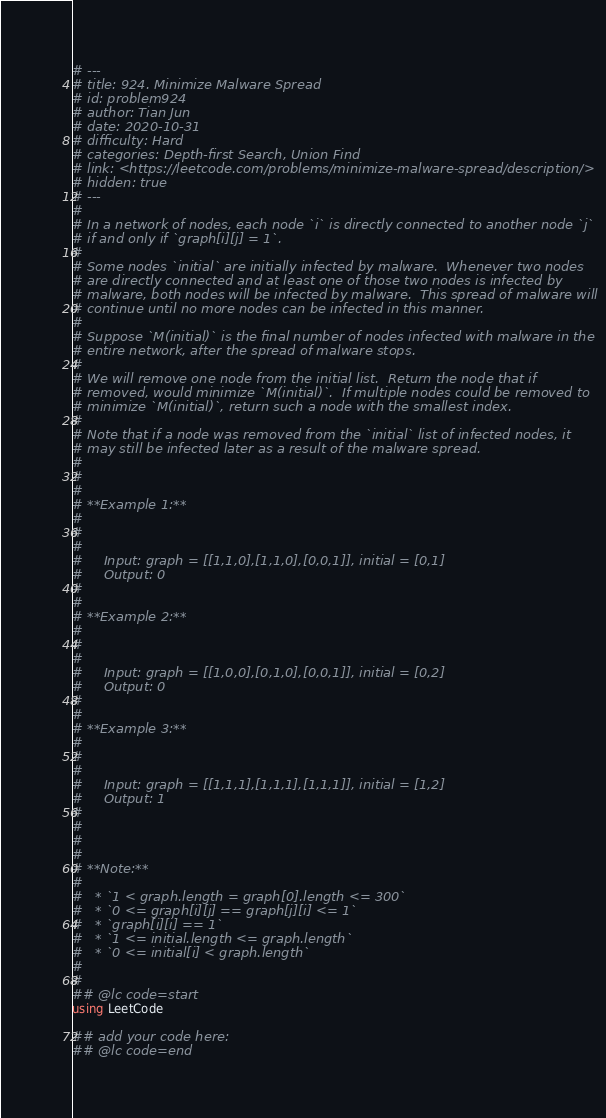Convert code to text. <code><loc_0><loc_0><loc_500><loc_500><_Julia_># ---
# title: 924. Minimize Malware Spread
# id: problem924
# author: Tian Jun
# date: 2020-10-31
# difficulty: Hard
# categories: Depth-first Search, Union Find
# link: <https://leetcode.com/problems/minimize-malware-spread/description/>
# hidden: true
# ---
# 
# In a network of nodes, each node `i` is directly connected to another node `j`
# if and only if `graph[i][j] = 1`.
# 
# Some nodes `initial` are initially infected by malware.  Whenever two nodes
# are directly connected and at least one of those two nodes is infected by
# malware, both nodes will be infected by malware.  This spread of malware will
# continue until no more nodes can be infected in this manner.
# 
# Suppose `M(initial)` is the final number of nodes infected with malware in the
# entire network, after the spread of malware stops.
# 
# We will remove one node from the initial list.  Return the node that if
# removed, would minimize `M(initial)`.  If multiple nodes could be removed to
# minimize `M(initial)`, return such a node with the smallest index.
# 
# Note that if a node was removed from the `initial` list of infected nodes, it
# may still be infected later as a result of the malware spread.
# 
# 
# 
# **Example 1:**
# 
#     
#     
#     Input: graph = [[1,1,0],[1,1,0],[0,0,1]], initial = [0,1]
#     Output: 0
#     
# 
# **Example 2:**
# 
#     
#     
#     Input: graph = [[1,0,0],[0,1,0],[0,0,1]], initial = [0,2]
#     Output: 0
#     
# 
# **Example 3:**
# 
#     
#     
#     Input: graph = [[1,1,1],[1,1,1],[1,1,1]], initial = [1,2]
#     Output: 1
#     
# 
# 
# 
# **Note:**
# 
#   * `1 < graph.length = graph[0].length <= 300`
#   * `0 <= graph[i][j] == graph[j][i] <= 1`
#   * `graph[i][i] == 1`
#   * `1 <= initial.length <= graph.length`
#   * `0 <= initial[i] < graph.length`
# 
# 
## @lc code=start
using LeetCode

## add your code here:
## @lc code=end
</code> 